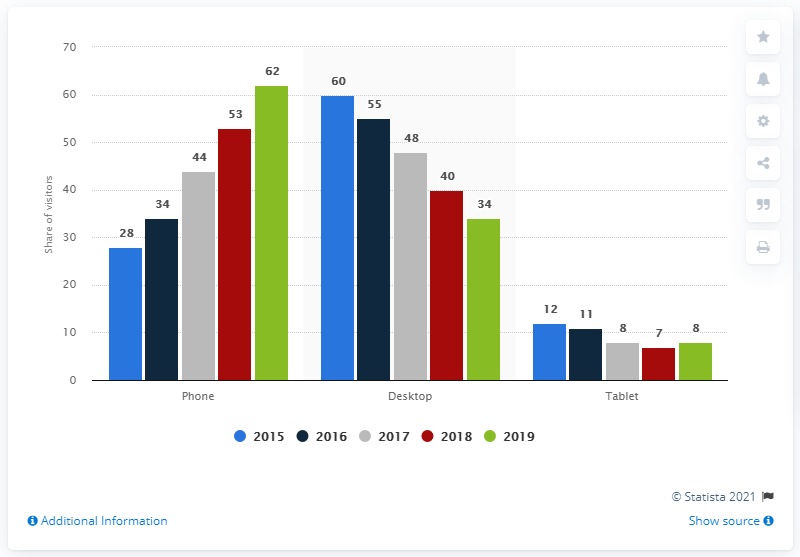Give some essential details in this illustration. The average phone use across all years is 44.2. By 2019, approximately 60% of Pornhub.com users in Russia accessed the platform via smartphones. In 2019, the highest usage of smartphones was recorded. The share of Pornhub.com users decreased by 60% compared to the previous year. 